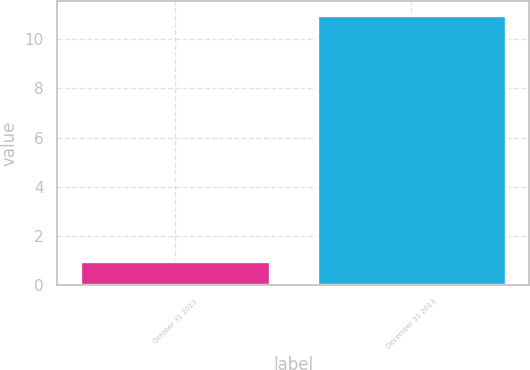Convert chart. <chart><loc_0><loc_0><loc_500><loc_500><bar_chart><fcel>October 31 2013<fcel>December 31 2013<nl><fcel>1<fcel>11<nl></chart> 